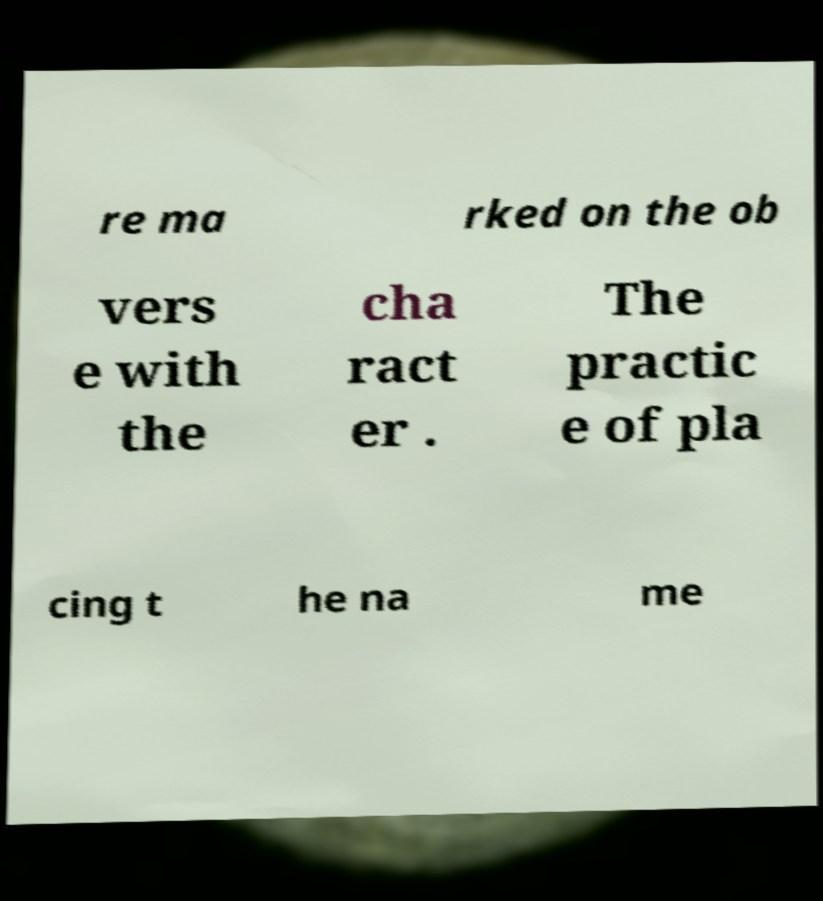Please read and relay the text visible in this image. What does it say? re ma rked on the ob vers e with the cha ract er . The practic e of pla cing t he na me 